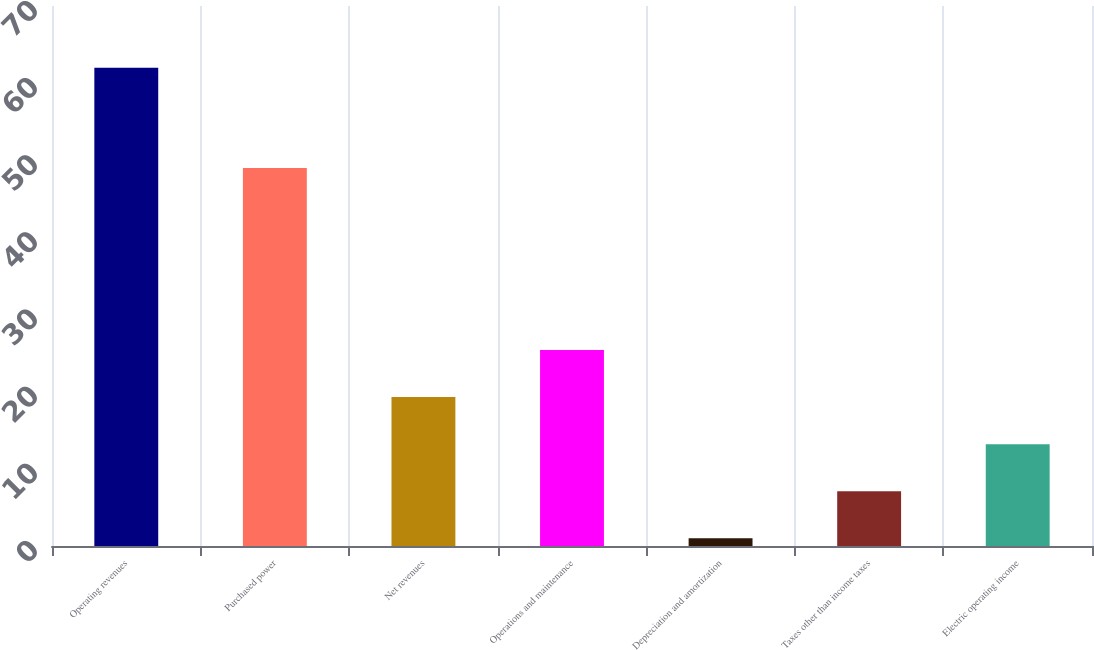Convert chart. <chart><loc_0><loc_0><loc_500><loc_500><bar_chart><fcel>Operating revenues<fcel>Purchased power<fcel>Net revenues<fcel>Operations and maintenance<fcel>Depreciation and amortization<fcel>Taxes other than income taxes<fcel>Electric operating income<nl><fcel>62<fcel>49<fcel>19.3<fcel>25.4<fcel>1<fcel>7.1<fcel>13.2<nl></chart> 